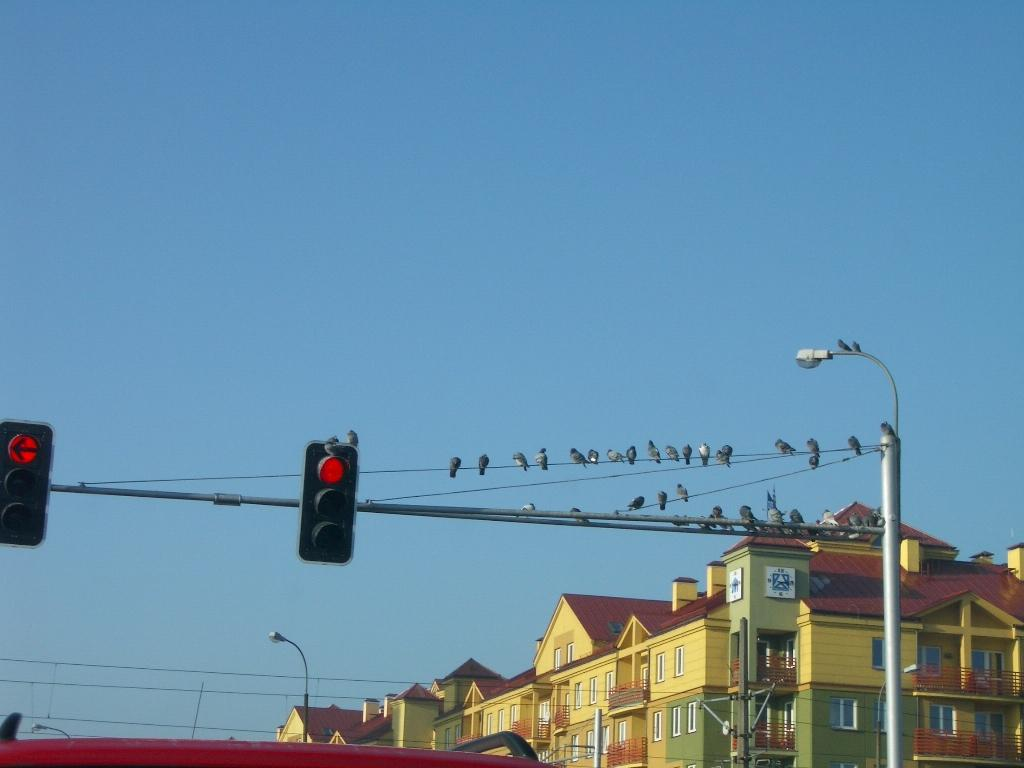What type of signals are present in the image? There are traffic signals in the image. What are the poles supporting in the image? The poles are supporting lights in the image. Can you describe the birds in the image? There are birds on wires in the image. What type of structures can be seen in the image? There are buildings with windows in the image. What else is present in the image besides the traffic signals, poles, lights, birds, and buildings? There are objects in the image. What can be seen in the background of the image? The sky is visible in the background of the image. How many potatoes are visible in the image? There are no potatoes present in the image. What type of approval is being given by the birds in the image? There are no birds giving approval in the image; they are simply perched on wires. Can you describe the rabbits in the image? There are no rabbits present in the image. 